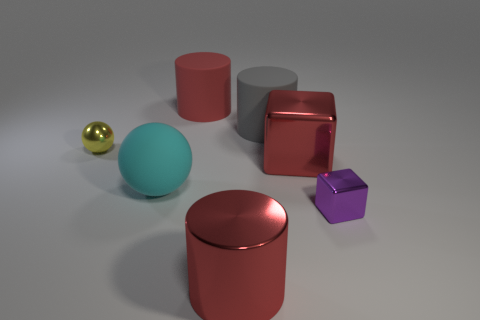There is a big metal object that is the same color as the big metal cylinder; what shape is it?
Offer a very short reply. Cube. Does the metal cylinder have the same color as the metal block behind the big cyan object?
Keep it short and to the point. Yes. How many other objects are there of the same material as the big cube?
Offer a very short reply. 3. Are there more big red objects than large things?
Keep it short and to the point. No. There is a large shiny thing in front of the cyan rubber sphere; is its color the same as the big metal cube?
Offer a terse response. Yes. What color is the tiny metallic sphere?
Provide a succinct answer. Yellow. There is a thing that is to the left of the large cyan object; is there a thing behind it?
Offer a terse response. Yes. There is a yellow shiny thing on the left side of the large cyan matte object on the right side of the yellow metal ball; what shape is it?
Ensure brevity in your answer.  Sphere. Is the number of large red cubes less than the number of large green shiny blocks?
Your response must be concise. No. Is the material of the small block the same as the big cube?
Provide a succinct answer. Yes. 